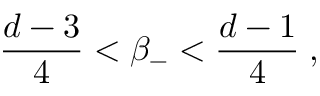Convert formula to latex. <formula><loc_0><loc_0><loc_500><loc_500>\frac { d - 3 } { 4 } < \beta _ { - } < \frac { d - 1 } { 4 } \, ,</formula> 